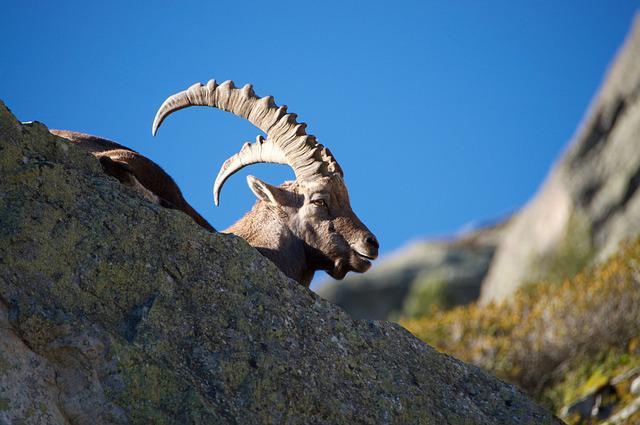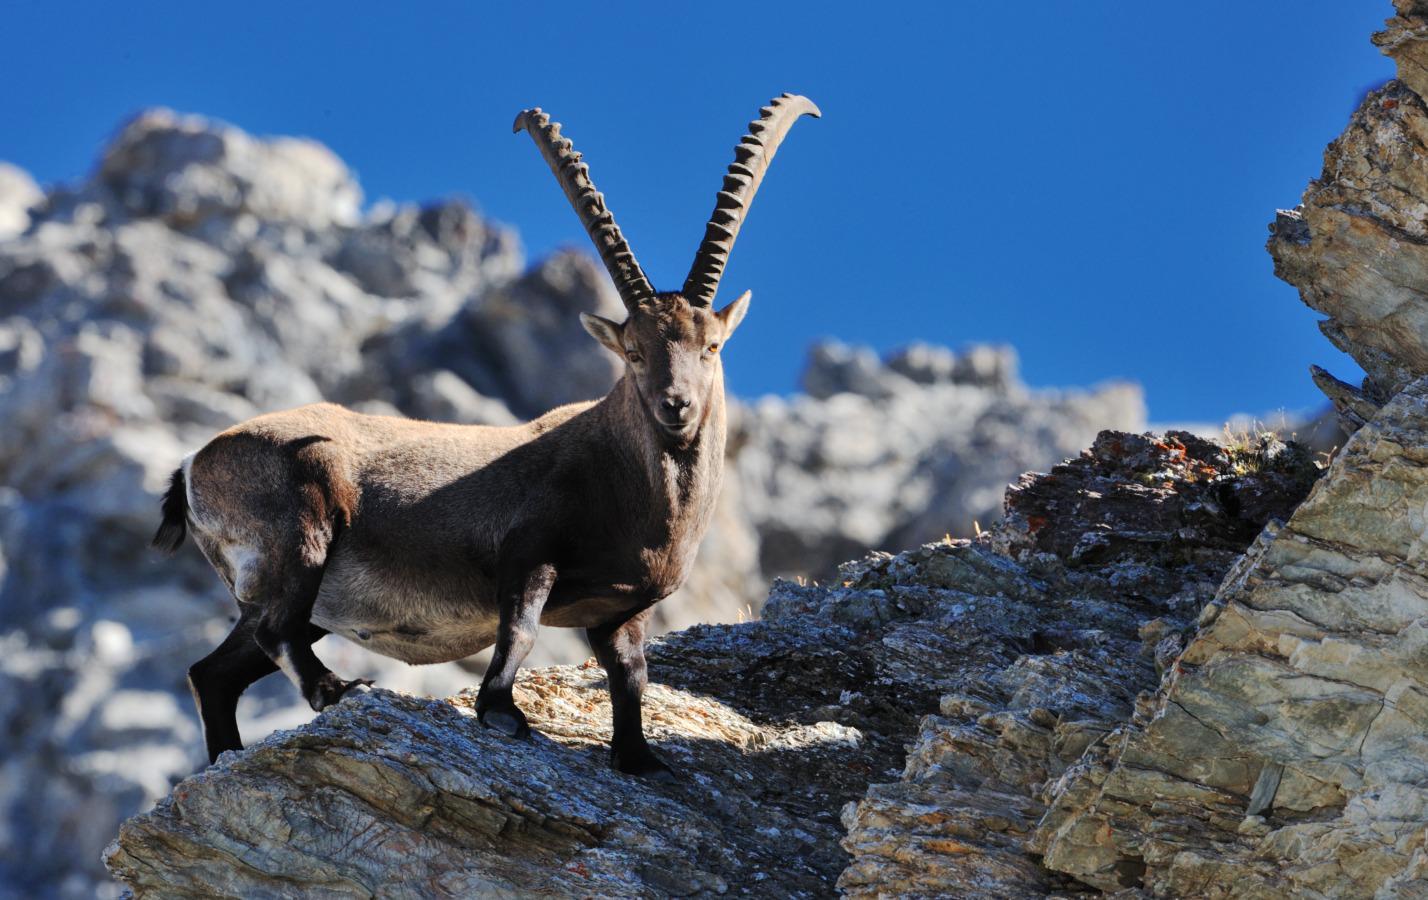The first image is the image on the left, the second image is the image on the right. For the images shown, is this caption "All images have a blue background; not a cloud in the sky." true? Answer yes or no. Yes. 